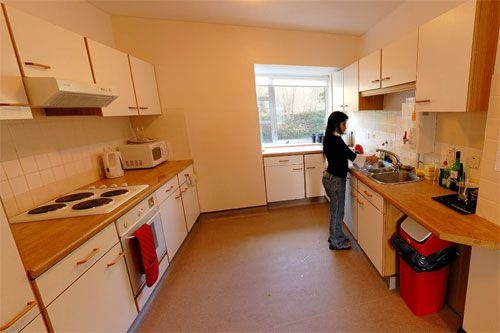Describe the objects in this image and their specific colors. I can see oven in tan, maroon, brown, and darkgray tones, people in tan, black, maroon, and gray tones, microwave in tan, red, salmon, and maroon tones, sink in tan, maroon, black, and gray tones, and bottle in tan, black, olive, and maroon tones in this image. 